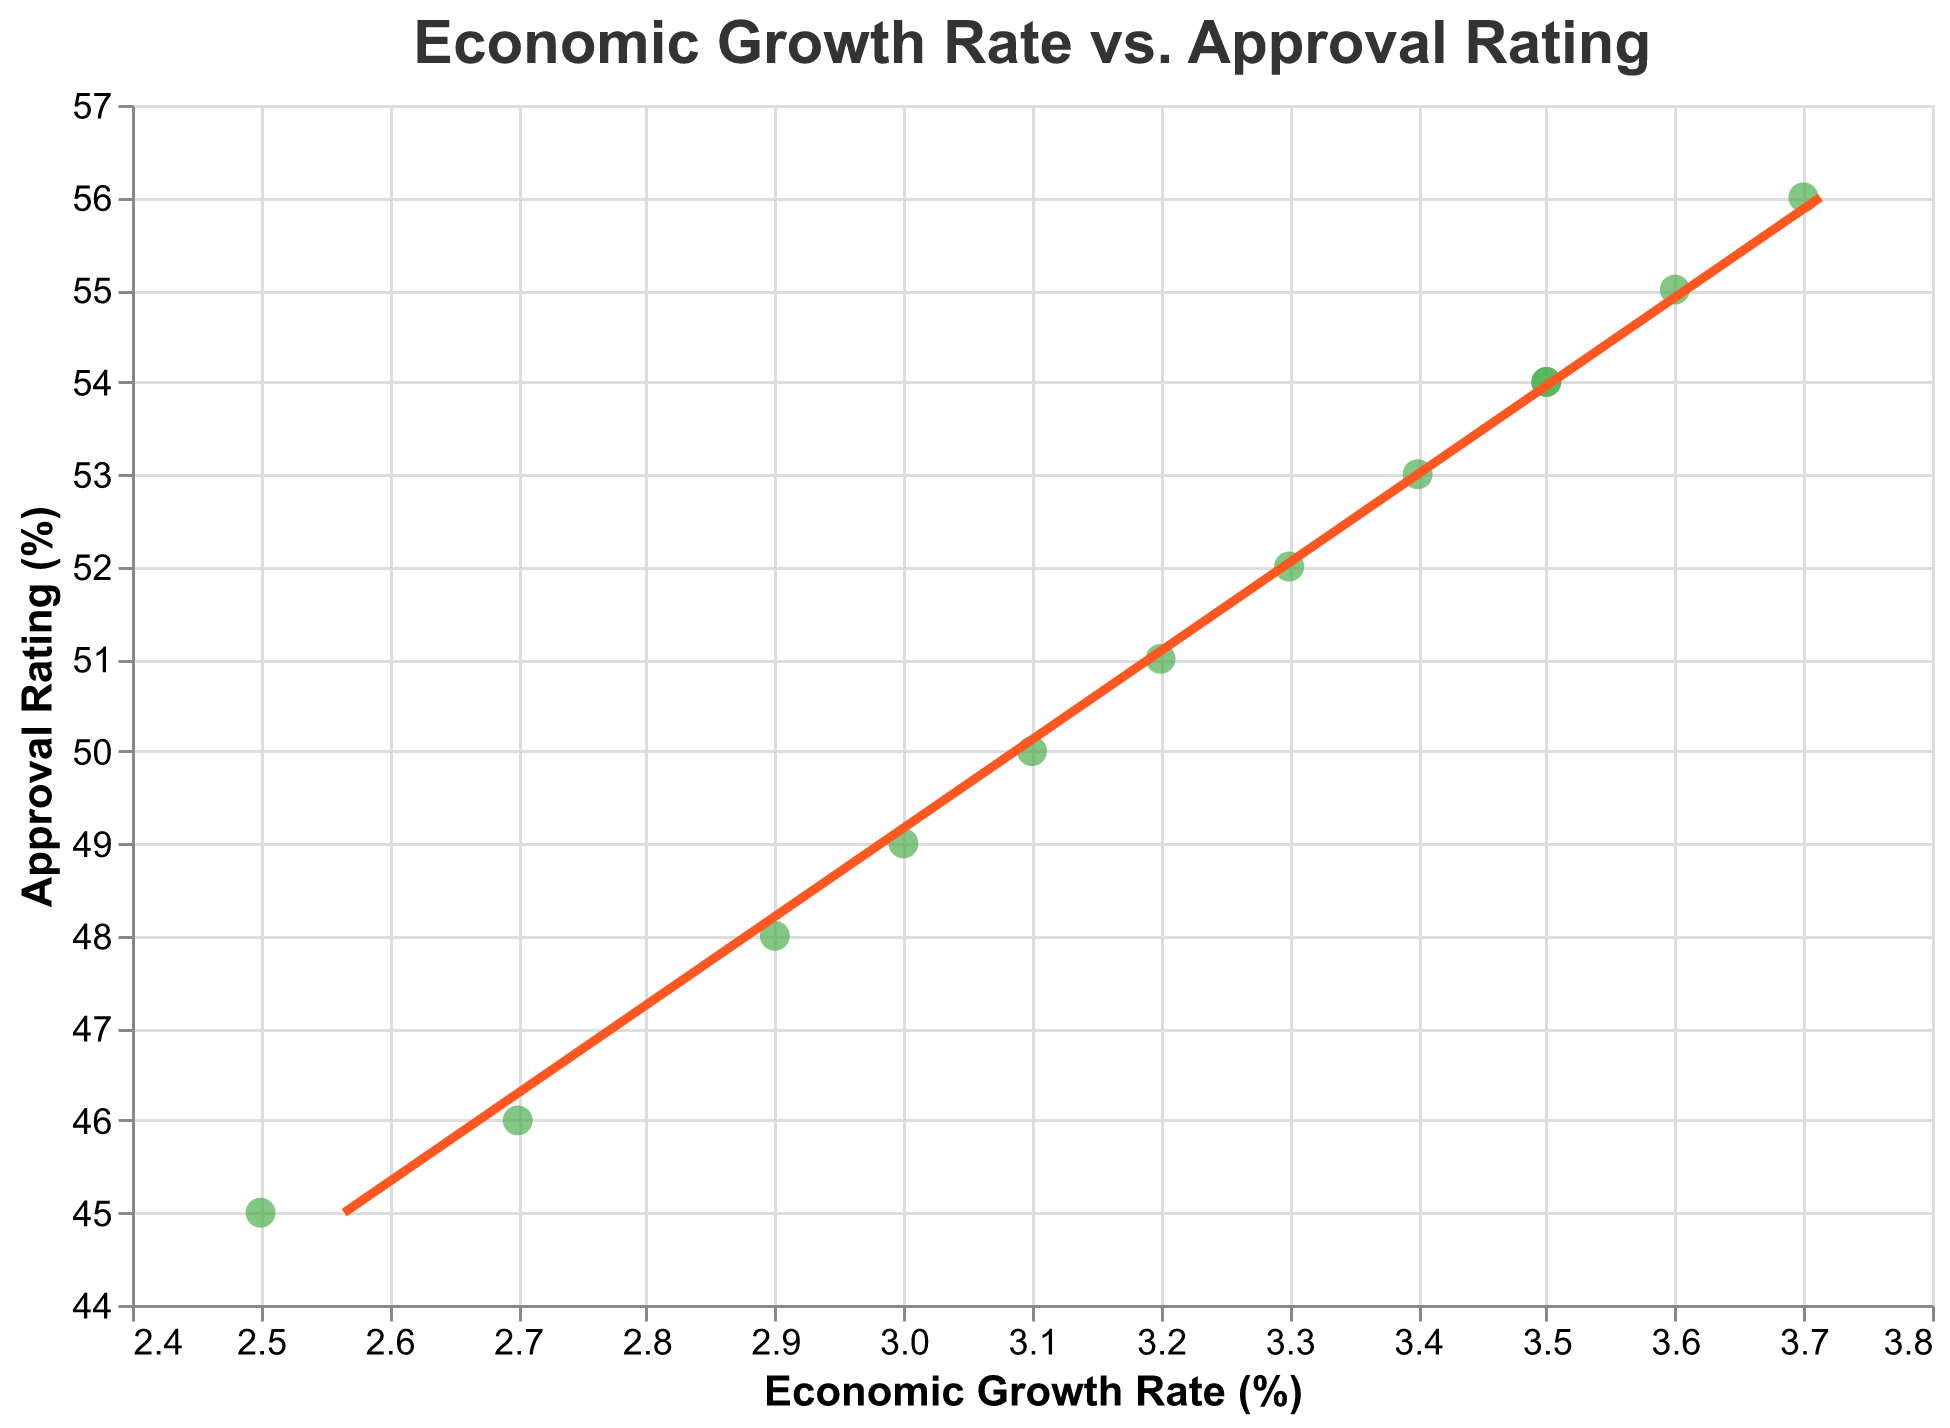What is the title of the figure? The title of the figure is displayed at the top of the chart.
Answer: Economic Growth Rate vs. Approval Rating How many data points are present in the scatter plot? Each point on the scatter plot represents a data entry. Count the number of points to get the total.
Answer: 12 What is the color of the trend line? The trend line is represented by a continuous line, and its color can be identified by visually inspecting the line.
Answer: Red (or "#FF5722") What is the approval rating when the economic growth rate is 3.0%? Find the point where Economic Growth Rate is 3.0% on the x-axis and check the corresponding Approval Rating on the y-axis.
Answer: 49% How does the approval rating change as the economic growth rate increases from 2.5% to 3.7%? Observe the trend of the data points from left to right, starting from an Economic Growth Rate of 2.5% to 3.7% and noting the corresponding Approval Ratings.
Answer: It increases What is the range of the Economic Growth Rate displayed on the x-axis? The x-axis displays the Economic Growth Rate, with the minimum and maximum values of the range shown at the ends.
Answer: 2.4% to 3.8% During which month was the highest approval rating recorded and what was the economic growth rate at that time? Identify the point with the highest approval rating on the y-axis and note its date and corresponding economic growth rate.
Answer: November 2022, 3.7% What is the relationship between economic growth rate and approval rating according to the trend line? Examine the slope of the trend line; if it slopes upward, the relationship is positive; if downward, negative.
Answer: Positive Is there any month where the Approval Rating is equal to the Economic Growth Rate multiplied by 10? Check if for any data point, Approval Rating equals Economic Growth Rate multiplied by 10. For example, if Economic Growth Rate is 2.9%, is Approval Rating 29%? Repeat for all data points.
Answer: No By how much did the approval rating increase from January 2022 to June 2022, and what was the corresponding change in the economic growth rate? Calculate the difference in the approval ratings and economic growth rates for the months of January 2022 and June 2022.
Answer: Approval Rating increased by 7%, and Economic Growth Rate increased by 0.8% 